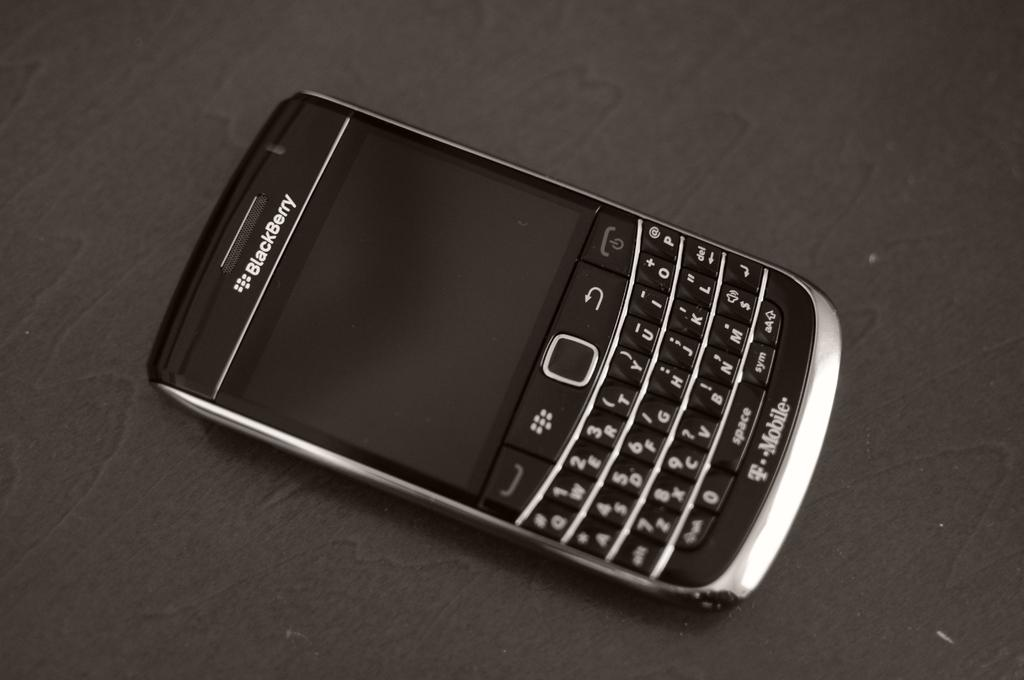<image>
Provide a brief description of the given image. A T Mobile Blackberry phone sits on a table showing a blank screen and a complete QWERTY keyboard. 